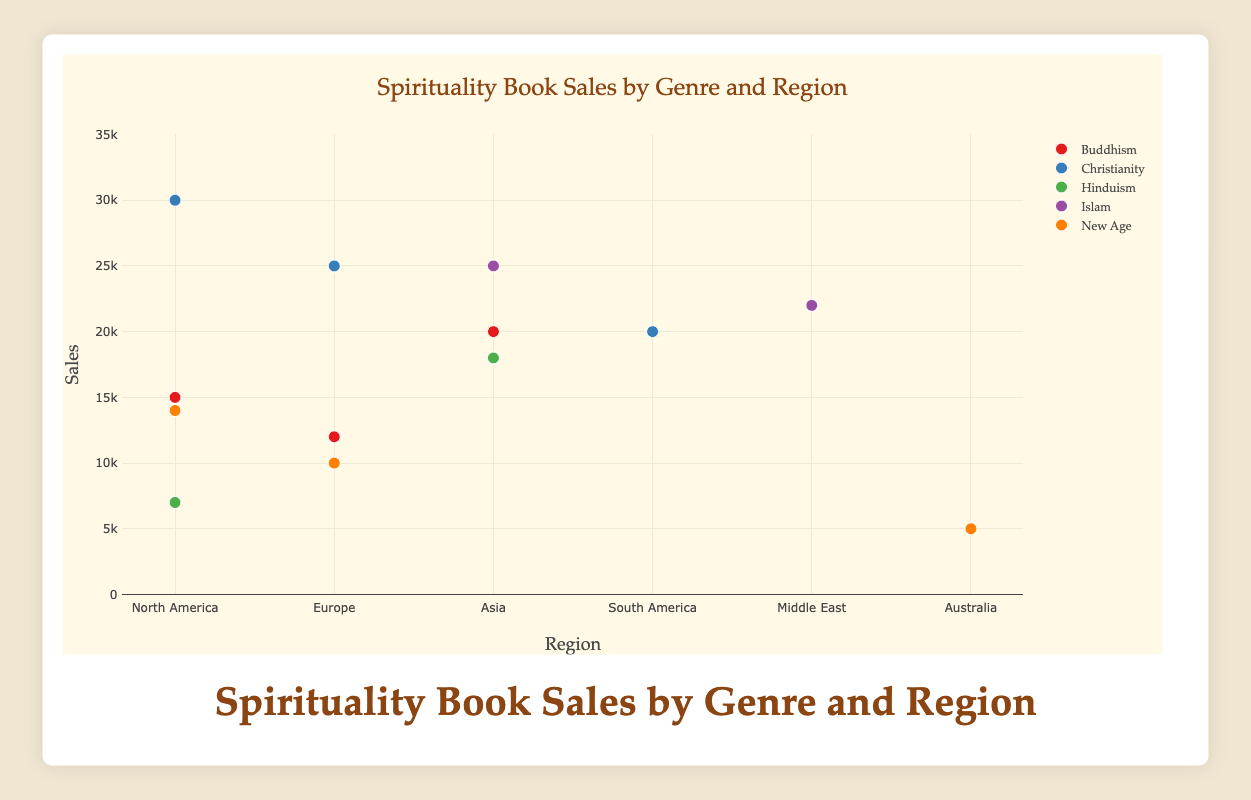Which genre has the highest book sales in North America? To determine the genre with the highest sales in North America, look at the y-coordinates of the data points corresponding to North America and compare their heights. Christianity has a data point at 30,000 sales, which is the highest.
Answer: Christianity How many genres are shown in the plot? The number of distinct genres can be counted by observing the legend, which lists all the genres. The plot shows five genres: Buddhism, Christianity, Hinduism, Islam, and New Age.
Answer: 5 What is the total sales of Buddhism books in all regions? To find the total sales for Buddhism, sum the sales from all regions. The sales are: 15,000 (North America) + 12,000 (Europe) + 20,000 (Asia) = 47,000.
Answer: 47,000 Which region has the least sales for New Age books? To find the region with the least sales for New Age books, compare the sales values for each region. The values are: 14,000 (North America), 10,000 (Europe), and 5,000 (Australia). The least is Australia.
Answer: Australia Which genre has the most consistent (least varied) sales across different regions? A genre with the most consistent sales will have its sales points close to each other vertically. By visually inspecting the spread of each genre's sales points, Christianity appears consistent because its sales values (30,000, 25,000, and 20,000) are relatively close.
Answer: Christianity Compare the total sales of Islamic books and Hinduism books in Asia. Which one is higher? Look at the sales values for Islam and Hinduism in Asia. Islam has 25,000 sales and Hinduism has 18,000 sales. Comparing these, Islam has higher sales.
Answer: Islam What is the average sales of New Age books across all regions? To find the average, add up all sales of New Age (14,000 + 10,000 + 5,000 = 29,000) and divide by the number of regions (3). 29,000 / 3 = 9,667.
Answer: 9,667 Which genre has the largest range of book sales? To find the genre with the largest range, calculate the difference between the highest and lowest sales for each genre. The ranges are Buddhism (20,000 - 12,000 = 8,000), Christianity (30,000 - 20,000 = 10,000), Hinduism (18,000 - 7,000 = 11,000), Islam (25,000 - 10,000 = 15,000), New Age (14,000 - 5,000 = 9,000). Islam has the largest range of 15,000.
Answer: Islam What's the total sales for all genres in Europe? Sum the sales of all genres in Europe. The values are: 12,000 (Buddhism) + 25,000 (Christianity) + 10,000 (Islam) + 10,000 (New Age) = 57,000.
Answer: 57,000 